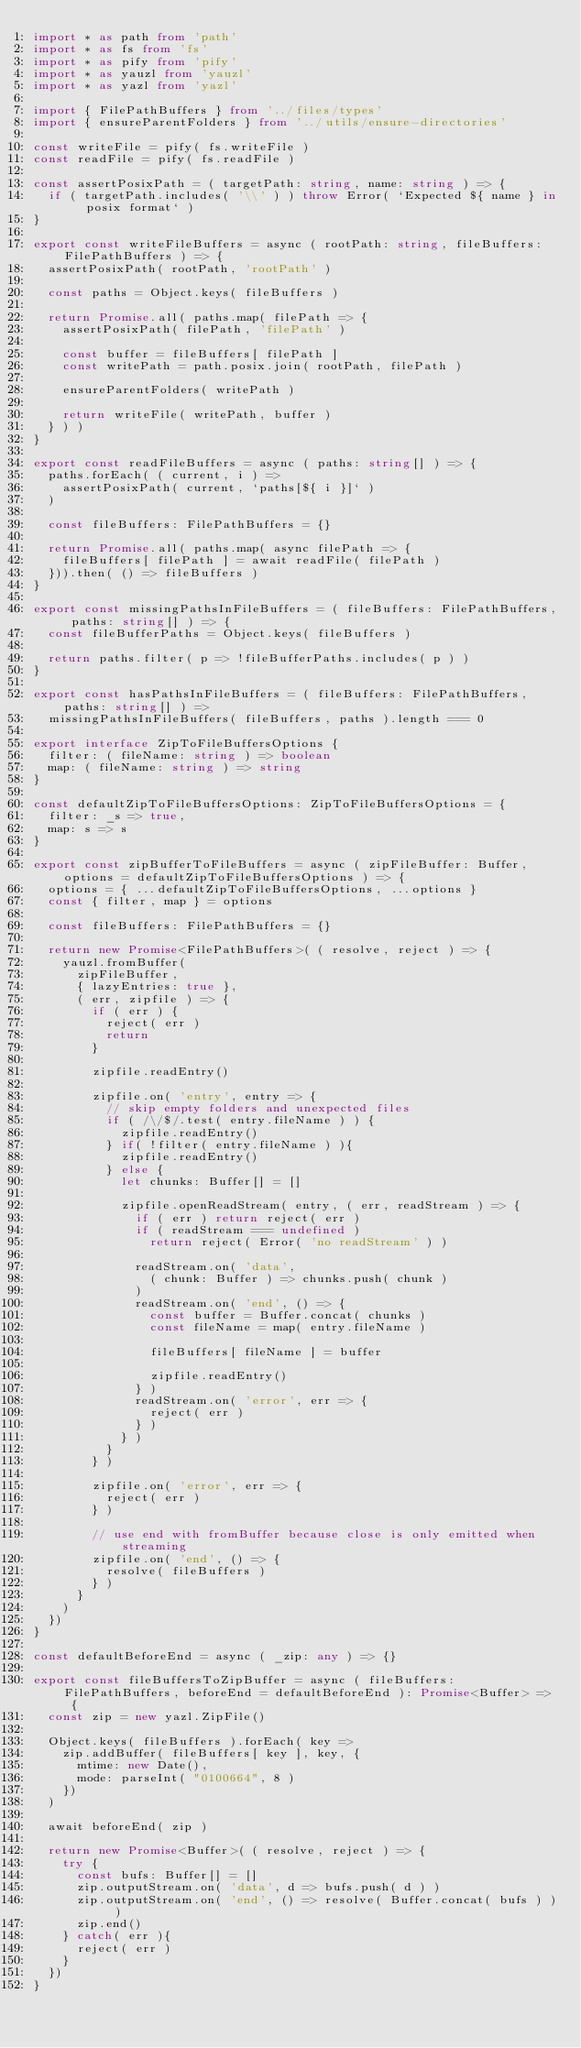Convert code to text. <code><loc_0><loc_0><loc_500><loc_500><_TypeScript_>import * as path from 'path'
import * as fs from 'fs'
import * as pify from 'pify'
import * as yauzl from 'yauzl'
import * as yazl from 'yazl'

import { FilePathBuffers } from '../files/types'
import { ensureParentFolders } from '../utils/ensure-directories'

const writeFile = pify( fs.writeFile )
const readFile = pify( fs.readFile )

const assertPosixPath = ( targetPath: string, name: string ) => {
  if ( targetPath.includes( '\\' ) ) throw Error( `Expected ${ name } in posix format` )
}

export const writeFileBuffers = async ( rootPath: string, fileBuffers: FilePathBuffers ) => {
  assertPosixPath( rootPath, 'rootPath' )

  const paths = Object.keys( fileBuffers )

  return Promise.all( paths.map( filePath => {
    assertPosixPath( filePath, 'filePath' )

    const buffer = fileBuffers[ filePath ]
    const writePath = path.posix.join( rootPath, filePath )

    ensureParentFolders( writePath )

    return writeFile( writePath, buffer )
  } ) )
}

export const readFileBuffers = async ( paths: string[] ) => {
  paths.forEach( ( current, i ) =>
    assertPosixPath( current, `paths[${ i }]` )
  )

  const fileBuffers: FilePathBuffers = {}

  return Promise.all( paths.map( async filePath => {
    fileBuffers[ filePath ] = await readFile( filePath )
  })).then( () => fileBuffers )
}

export const missingPathsInFileBuffers = ( fileBuffers: FilePathBuffers, paths: string[] ) => {
  const fileBufferPaths = Object.keys( fileBuffers )

  return paths.filter( p => !fileBufferPaths.includes( p ) )
}

export const hasPathsInFileBuffers = ( fileBuffers: FilePathBuffers, paths: string[] ) =>
  missingPathsInFileBuffers( fileBuffers, paths ).length === 0

export interface ZipToFileBuffersOptions {
  filter: ( fileName: string ) => boolean
  map: ( fileName: string ) => string
}

const defaultZipToFileBuffersOptions: ZipToFileBuffersOptions = {
  filter: _s => true,
  map: s => s
}

export const zipBufferToFileBuffers = async ( zipFileBuffer: Buffer, options = defaultZipToFileBuffersOptions ) => {
  options = { ...defaultZipToFileBuffersOptions, ...options }
  const { filter, map } = options

  const fileBuffers: FilePathBuffers = {}

  return new Promise<FilePathBuffers>( ( resolve, reject ) => {
    yauzl.fromBuffer(
      zipFileBuffer,
      { lazyEntries: true },
      ( err, zipfile ) => {
        if ( err ) {
          reject( err )
          return
        }

        zipfile.readEntry()

        zipfile.on( 'entry', entry => {
          // skip empty folders and unexpected files
          if ( /\/$/.test( entry.fileName ) ) {
            zipfile.readEntry()
          } if( !filter( entry.fileName ) ){
            zipfile.readEntry()
          } else {
            let chunks: Buffer[] = []

            zipfile.openReadStream( entry, ( err, readStream ) => {
              if ( err ) return reject( err )
              if ( readStream === undefined )
                return reject( Error( 'no readStream' ) )

              readStream.on( 'data',
                ( chunk: Buffer ) => chunks.push( chunk )
              )
              readStream.on( 'end', () => {
                const buffer = Buffer.concat( chunks )
                const fileName = map( entry.fileName )

                fileBuffers[ fileName ] = buffer

                zipfile.readEntry()
              } )
              readStream.on( 'error', err => {
                reject( err )
              } )
            } )
          }
        } )

        zipfile.on( 'error', err => {
          reject( err )
        } )

        // use end with fromBuffer because close is only emitted when streaming
        zipfile.on( 'end', () => {
          resolve( fileBuffers )
        } )
      }
    )
  })
}

const defaultBeforeEnd = async ( _zip: any ) => {}

export const fileBuffersToZipBuffer = async ( fileBuffers: FilePathBuffers, beforeEnd = defaultBeforeEnd ): Promise<Buffer> => {
  const zip = new yazl.ZipFile()

  Object.keys( fileBuffers ).forEach( key =>
    zip.addBuffer( fileBuffers[ key ], key, {
      mtime: new Date(),
      mode: parseInt( "0100664", 8 )
    })
  )

  await beforeEnd( zip )

  return new Promise<Buffer>( ( resolve, reject ) => {
    try {
      const bufs: Buffer[] = []
      zip.outputStream.on( 'data', d => bufs.push( d ) )
      zip.outputStream.on( 'end', () => resolve( Buffer.concat( bufs ) ) )
      zip.end()
    } catch( err ){
      reject( err )
    }
  })
}</code> 